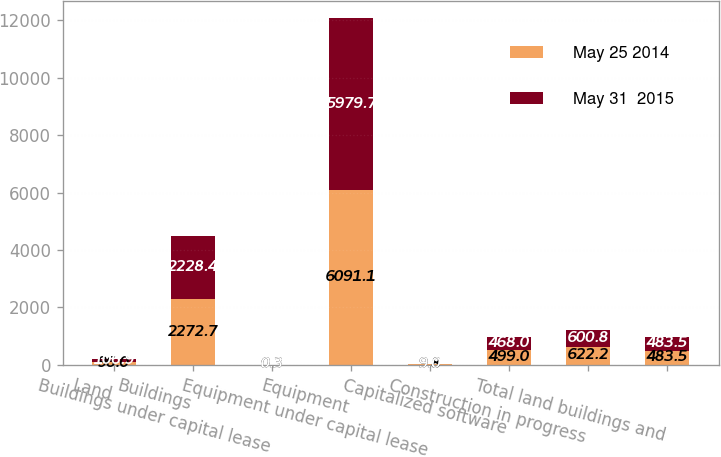Convert chart to OTSL. <chart><loc_0><loc_0><loc_500><loc_500><stacked_bar_chart><ecel><fcel>Land<fcel>Buildings<fcel>Buildings under capital lease<fcel>Equipment<fcel>Equipment under capital lease<fcel>Capitalized software<fcel>Construction in progress<fcel>Total land buildings and<nl><fcel>May 25 2014<fcel>96<fcel>2272.7<fcel>0.3<fcel>6091.1<fcel>9.8<fcel>499<fcel>622.2<fcel>483.5<nl><fcel>May 31  2015<fcel>106.9<fcel>2228.4<fcel>0.3<fcel>5979.7<fcel>9<fcel>468<fcel>600.8<fcel>483.5<nl></chart> 